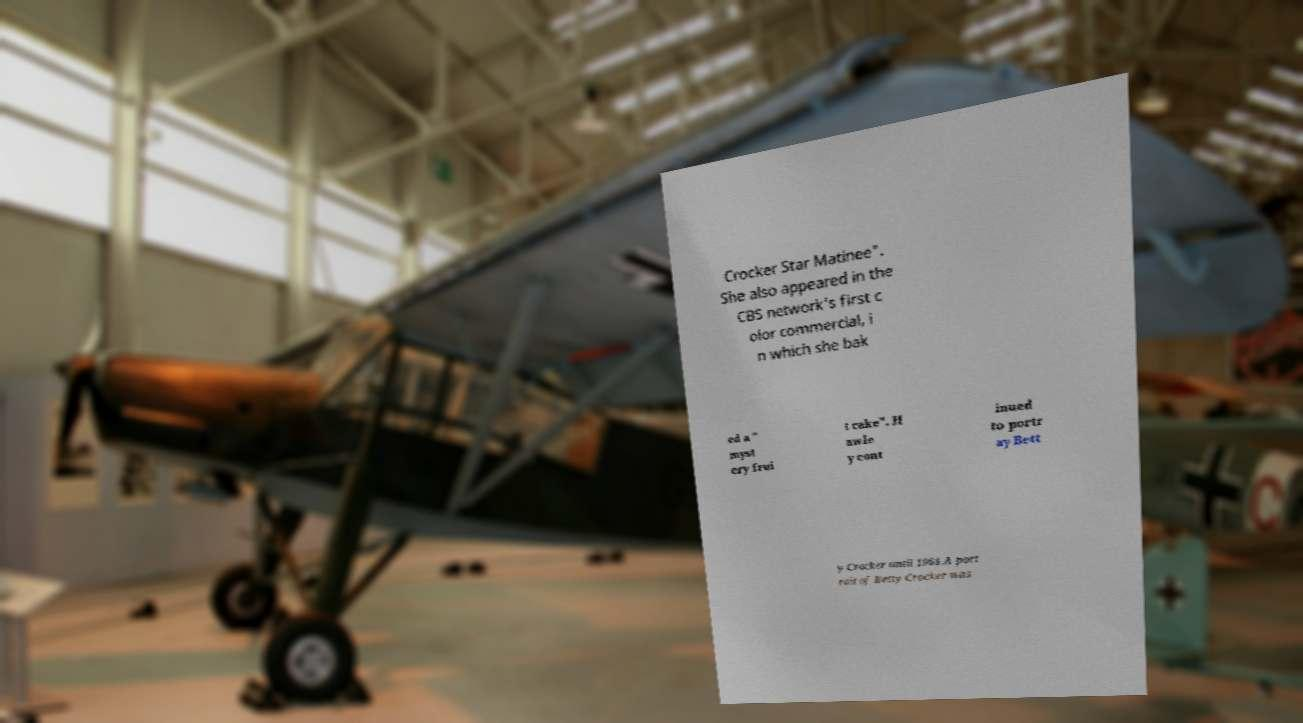What messages or text are displayed in this image? I need them in a readable, typed format. Crocker Star Matinee". She also appeared in the CBS network's first c olor commercial, i n which she bak ed a " myst ery frui t cake". H awle y cont inued to portr ay Bett y Crocker until 1964.A port rait of Betty Crocker was 